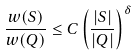<formula> <loc_0><loc_0><loc_500><loc_500>\frac { w ( S ) } { w ( Q ) } \leq C \left ( \frac { | S | } { | Q | } \right ) ^ { \delta }</formula> 